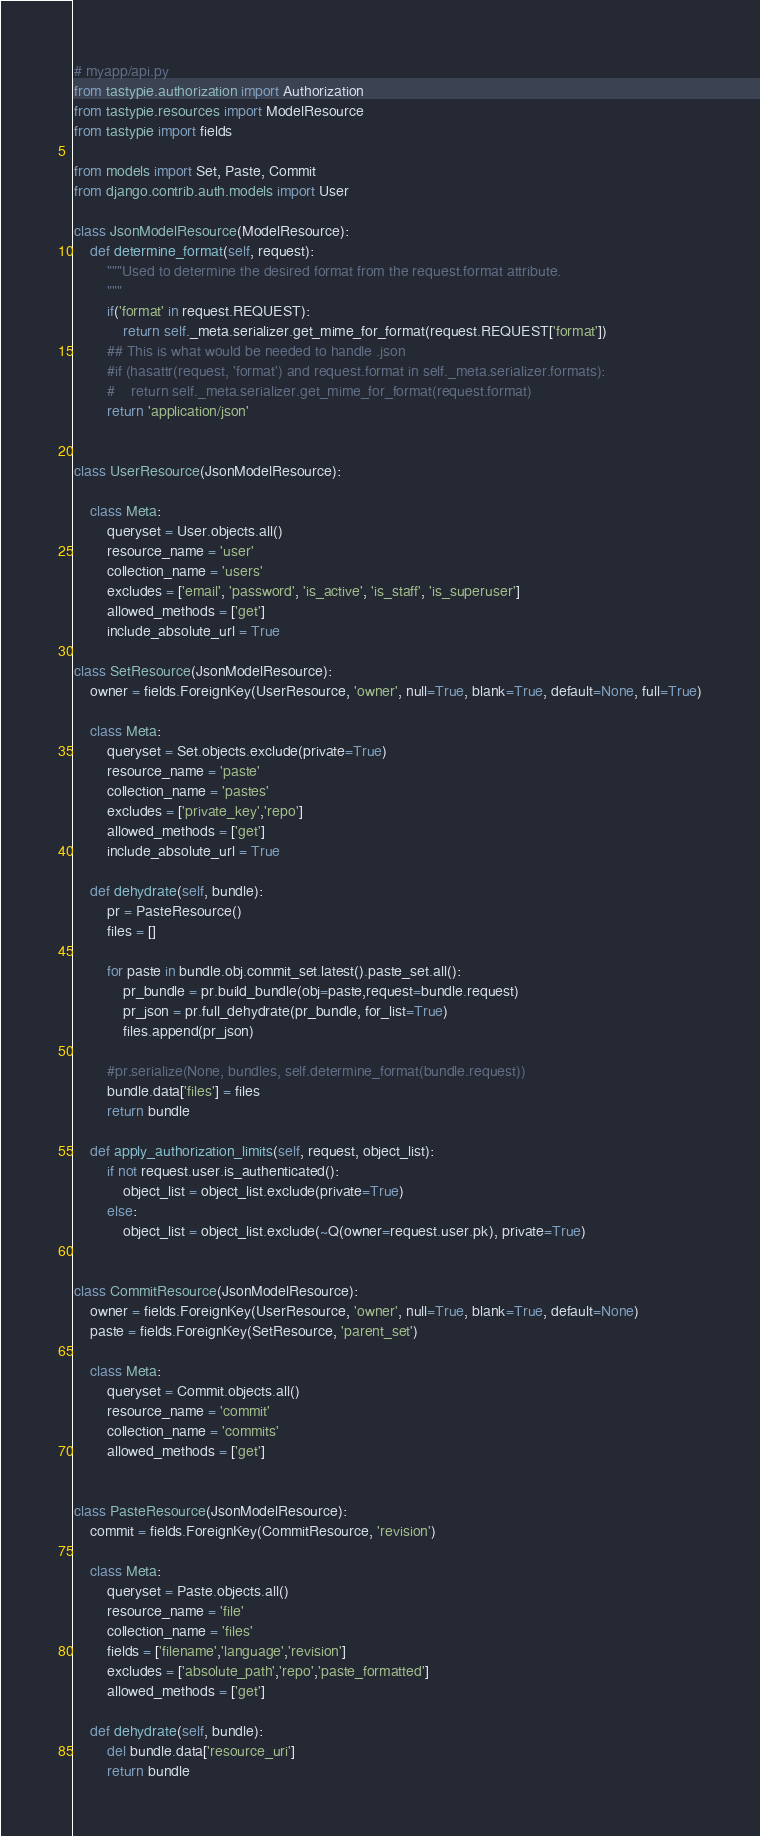<code> <loc_0><loc_0><loc_500><loc_500><_Python_># myapp/api.py
from tastypie.authorization import Authorization
from tastypie.resources import ModelResource
from tastypie import fields

from models import Set, Paste, Commit
from django.contrib.auth.models import User

class JsonModelResource(ModelResource):
    def determine_format(self, request):
        """Used to determine the desired format from the request.format attribute.
        """
        if('format' in request.REQUEST):
            return self._meta.serializer.get_mime_for_format(request.REQUEST['format'])
        ## This is what would be needed to handle .json
        #if (hasattr(request, 'format') and request.format in self._meta.serializer.formats):
        #    return self._meta.serializer.get_mime_for_format(request.format)
        return 'application/json'


class UserResource(JsonModelResource):

    class Meta:
        queryset = User.objects.all()
        resource_name = 'user'
        collection_name = 'users'
        excludes = ['email', 'password', 'is_active', 'is_staff', 'is_superuser']
        allowed_methods = ['get']
        include_absolute_url = True

class SetResource(JsonModelResource):
    owner = fields.ForeignKey(UserResource, 'owner', null=True, blank=True, default=None, full=True)

    class Meta:
        queryset = Set.objects.exclude(private=True)
        resource_name = 'paste'
        collection_name = 'pastes'
        excludes = ['private_key','repo']
        allowed_methods = ['get']
        include_absolute_url = True

    def dehydrate(self, bundle):
        pr = PasteResource()
        files = []
        
        for paste in bundle.obj.commit_set.latest().paste_set.all():
            pr_bundle = pr.build_bundle(obj=paste,request=bundle.request)
            pr_json = pr.full_dehydrate(pr_bundle, for_list=True)
            files.append(pr_json)
        
        #pr.serialize(None, bundles, self.determine_format(bundle.request))
        bundle.data['files'] = files
        return bundle

    def apply_authorization_limits(self, request, object_list):
        if not request.user.is_authenticated():
            object_list = object_list.exclude(private=True)
        else:
            object_list = object_list.exclude(~Q(owner=request.user.pk), private=True)


class CommitResource(JsonModelResource):
    owner = fields.ForeignKey(UserResource, 'owner', null=True, blank=True, default=None)
    paste = fields.ForeignKey(SetResource, 'parent_set')

    class Meta:
        queryset = Commit.objects.all()
        resource_name = 'commit'
        collection_name = 'commits'
        allowed_methods = ['get']


class PasteResource(JsonModelResource):
    commit = fields.ForeignKey(CommitResource, 'revision')

    class Meta:
        queryset = Paste.objects.all()
        resource_name = 'file'
        collection_name = 'files'
        fields = ['filename','language','revision']
        excludes = ['absolute_path','repo','paste_formatted']
        allowed_methods = ['get']

    def dehydrate(self, bundle):
        del bundle.data['resource_uri']
        return bundle
</code> 